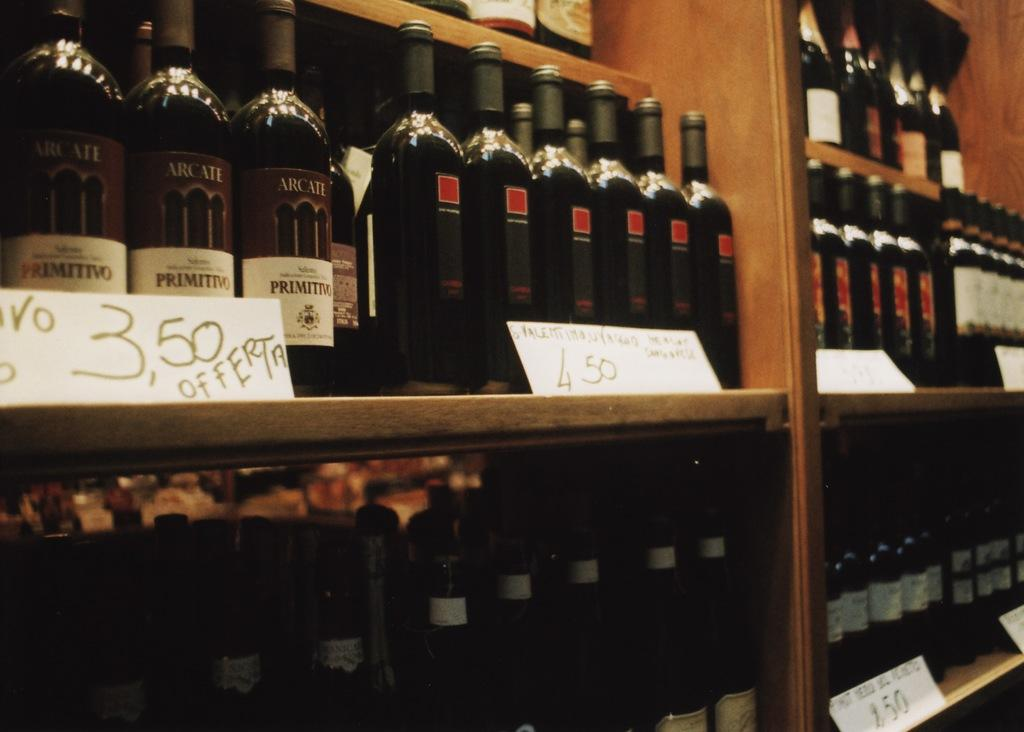<image>
Describe the image concisely. Shelves are filled with rows of wines after wines including Primitivo wines. 